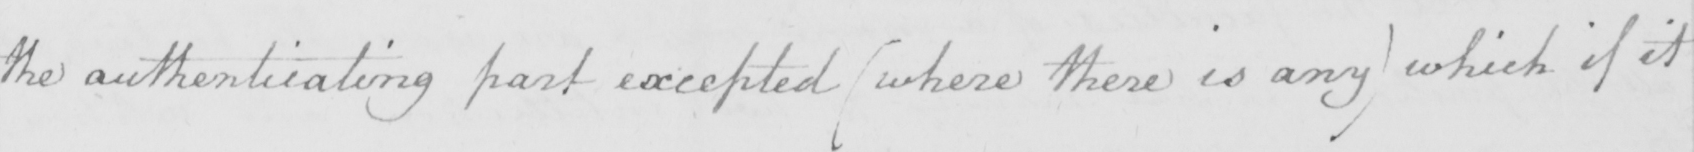Can you read and transcribe this handwriting? the authenticating part excepted  ( where there is any )  which if it 